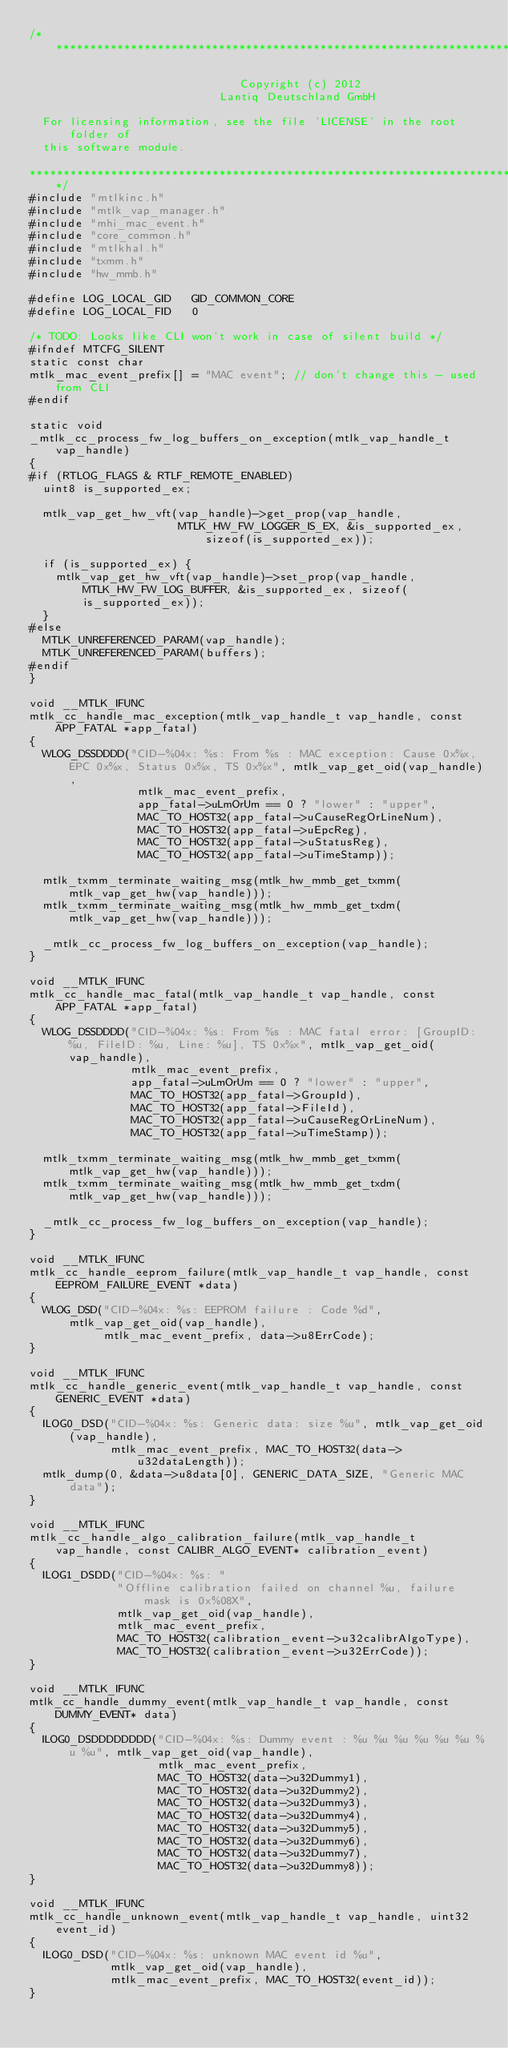Convert code to text. <code><loc_0><loc_0><loc_500><loc_500><_C_>/******************************************************************************

                               Copyright (c) 2012
                            Lantiq Deutschland GmbH

  For licensing information, see the file 'LICENSE' in the root folder of
  this software module.

******************************************************************************/
#include "mtlkinc.h"
#include "mtlk_vap_manager.h"
#include "mhi_mac_event.h"
#include "core_common.h"
#include "mtlkhal.h"
#include "txmm.h"
#include "hw_mmb.h"

#define LOG_LOCAL_GID   GID_COMMON_CORE
#define LOG_LOCAL_FID   0

/* TODO: Looks like CLI won't work in case of silent build */
#ifndef MTCFG_SILENT
static const char
mtlk_mac_event_prefix[] = "MAC event"; // don't change this - used from CLI
#endif

static void
_mtlk_cc_process_fw_log_buffers_on_exception(mtlk_vap_handle_t vap_handle)
{
#if (RTLOG_FLAGS & RTLF_REMOTE_ENABLED)
  uint8 is_supported_ex;

  mtlk_vap_get_hw_vft(vap_handle)->get_prop(vap_handle,
                      MTLK_HW_FW_LOGGER_IS_EX, &is_supported_ex, sizeof(is_supported_ex));

  if (is_supported_ex) {
    mtlk_vap_get_hw_vft(vap_handle)->set_prop(vap_handle, MTLK_HW_FW_LOG_BUFFER, &is_supported_ex, sizeof(is_supported_ex));
  }
#else
  MTLK_UNREFERENCED_PARAM(vap_handle);
  MTLK_UNREFERENCED_PARAM(buffers);
#endif
}

void __MTLK_IFUNC
mtlk_cc_handle_mac_exception(mtlk_vap_handle_t vap_handle, const APP_FATAL *app_fatal)
{
  WLOG_DSSDDDD("CID-%04x: %s: From %s : MAC exception: Cause 0x%x, EPC 0x%x, Status 0x%x, TS 0x%x", mtlk_vap_get_oid(vap_handle),
                mtlk_mac_event_prefix,
                app_fatal->uLmOrUm == 0 ? "lower" : "upper",
                MAC_TO_HOST32(app_fatal->uCauseRegOrLineNum),
                MAC_TO_HOST32(app_fatal->uEpcReg),
                MAC_TO_HOST32(app_fatal->uStatusReg),
                MAC_TO_HOST32(app_fatal->uTimeStamp));

  mtlk_txmm_terminate_waiting_msg(mtlk_hw_mmb_get_txmm(mtlk_vap_get_hw(vap_handle)));
  mtlk_txmm_terminate_waiting_msg(mtlk_hw_mmb_get_txdm(mtlk_vap_get_hw(vap_handle)));

  _mtlk_cc_process_fw_log_buffers_on_exception(vap_handle);
}

void __MTLK_IFUNC
mtlk_cc_handle_mac_fatal(mtlk_vap_handle_t vap_handle, const APP_FATAL *app_fatal)
{
  WLOG_DSSDDDD("CID-%04x: %s: From %s : MAC fatal error: [GroupID: %u, FileID: %u, Line: %u], TS 0x%x", mtlk_vap_get_oid(vap_handle),
               mtlk_mac_event_prefix,
               app_fatal->uLmOrUm == 0 ? "lower" : "upper",
               MAC_TO_HOST32(app_fatal->GroupId),
               MAC_TO_HOST32(app_fatal->FileId),
               MAC_TO_HOST32(app_fatal->uCauseRegOrLineNum),
               MAC_TO_HOST32(app_fatal->uTimeStamp));

  mtlk_txmm_terminate_waiting_msg(mtlk_hw_mmb_get_txmm(mtlk_vap_get_hw(vap_handle)));
  mtlk_txmm_terminate_waiting_msg(mtlk_hw_mmb_get_txdm(mtlk_vap_get_hw(vap_handle)));

  _mtlk_cc_process_fw_log_buffers_on_exception(vap_handle);
}

void __MTLK_IFUNC
mtlk_cc_handle_eeprom_failure(mtlk_vap_handle_t vap_handle, const EEPROM_FAILURE_EVENT *data)
{
  WLOG_DSD("CID-%04x: %s: EEPROM failure : Code %d", mtlk_vap_get_oid(vap_handle),
           mtlk_mac_event_prefix, data->u8ErrCode);
}

void __MTLK_IFUNC
mtlk_cc_handle_generic_event(mtlk_vap_handle_t vap_handle, const GENERIC_EVENT *data)
{
  ILOG0_DSD("CID-%04x: %s: Generic data: size %u", mtlk_vap_get_oid(vap_handle),
            mtlk_mac_event_prefix, MAC_TO_HOST32(data->u32dataLength));
  mtlk_dump(0, &data->u8data[0], GENERIC_DATA_SIZE, "Generic MAC data");
}

void __MTLK_IFUNC
mtlk_cc_handle_algo_calibration_failure(mtlk_vap_handle_t vap_handle, const CALIBR_ALGO_EVENT* calibration_event)
{
  ILOG1_DSDD("CID-%04x: %s: "
             "Offline calibration failed on channel %u, failure mask is 0x%08X",
             mtlk_vap_get_oid(vap_handle),
             mtlk_mac_event_prefix,
             MAC_TO_HOST32(calibration_event->u32calibrAlgoType),
             MAC_TO_HOST32(calibration_event->u32ErrCode));
}

void __MTLK_IFUNC
mtlk_cc_handle_dummy_event(mtlk_vap_handle_t vap_handle, const DUMMY_EVENT* data)
{
  ILOG0_DSDDDDDDDD("CID-%04x: %s: Dummy event : %u %u %u %u %u %u %u %u", mtlk_vap_get_oid(vap_handle),
                   mtlk_mac_event_prefix,
                   MAC_TO_HOST32(data->u32Dummy1),
                   MAC_TO_HOST32(data->u32Dummy2),
                   MAC_TO_HOST32(data->u32Dummy3),
                   MAC_TO_HOST32(data->u32Dummy4),
                   MAC_TO_HOST32(data->u32Dummy5),
                   MAC_TO_HOST32(data->u32Dummy6),
                   MAC_TO_HOST32(data->u32Dummy7),
                   MAC_TO_HOST32(data->u32Dummy8));
}

void __MTLK_IFUNC
mtlk_cc_handle_unknown_event(mtlk_vap_handle_t vap_handle, uint32 event_id)
{
  ILOG0_DSD("CID-%04x: %s: unknown MAC event id %u",
            mtlk_vap_get_oid(vap_handle),
            mtlk_mac_event_prefix, MAC_TO_HOST32(event_id));
}
</code> 